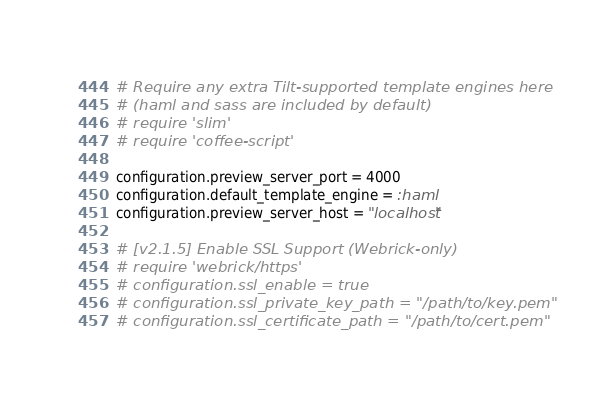<code> <loc_0><loc_0><loc_500><loc_500><_Ruby_># Require any extra Tilt-supported template engines here
# (haml and sass are included by default)
# require 'slim'
# require 'coffee-script'

configuration.preview_server_port = 4000
configuration.default_template_engine = :haml
configuration.preview_server_host = "localhost"

# [v2.1.5] Enable SSL Support (Webrick-only)
# require 'webrick/https'
# configuration.ssl_enable = true
# configuration.ssl_private_key_path = "/path/to/key.pem"
# configuration.ssl_certificate_path = "/path/to/cert.pem"
</code> 